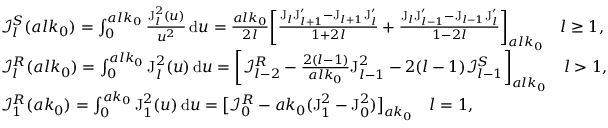Convert formula to latex. <formula><loc_0><loc_0><loc_500><loc_500>\begin{array} { r l } & { \mathcal { I } _ { l } ^ { S } ( a l k _ { 0 } ) = \int _ { 0 } ^ { a l k _ { 0 } } \frac { J _ { l } ^ { 2 } ( u ) } { u ^ { 2 } } \, d u = \frac { a l k _ { 0 } } { 2 l } \left [ \frac { J _ { l } J _ { l + 1 } ^ { \prime } - J _ { l + 1 } J _ { l } ^ { \prime } } { 1 + 2 l } + \frac { J _ { l } J _ { l - 1 } ^ { \prime } - J _ { l - 1 } J _ { l } ^ { \prime } } { 1 - 2 l } \right ] _ { a l k _ { 0 } } \quad l \geq 1 , } \\ & { \mathcal { I } _ { l } ^ { R } ( a l k _ { 0 } ) = \int _ { 0 } ^ { a l k _ { 0 } } J _ { l } ^ { 2 } ( u ) \, d u = \left [ \mathcal { I } _ { l - 2 } ^ { R } - \frac { 2 ( l - 1 ) } { a l k _ { 0 } } J _ { l - 1 } ^ { 2 } - 2 ( l - 1 ) \mathcal { I } _ { l - 1 } ^ { S } \right ] _ { a l k _ { 0 } } \quad l > 1 , } \\ & { \mathcal { I } _ { 1 } ^ { R } ( a k _ { 0 } ) = \int _ { 0 } ^ { a k _ { 0 } } J _ { 1 } ^ { 2 } ( u ) \, d u = \left [ \mathcal { I } _ { 0 } ^ { R } - a k _ { 0 } ( J _ { 1 } ^ { 2 } - J _ { 0 } ^ { 2 } ) \right ] _ { a k _ { 0 } } \quad l = 1 , } \end{array}</formula> 